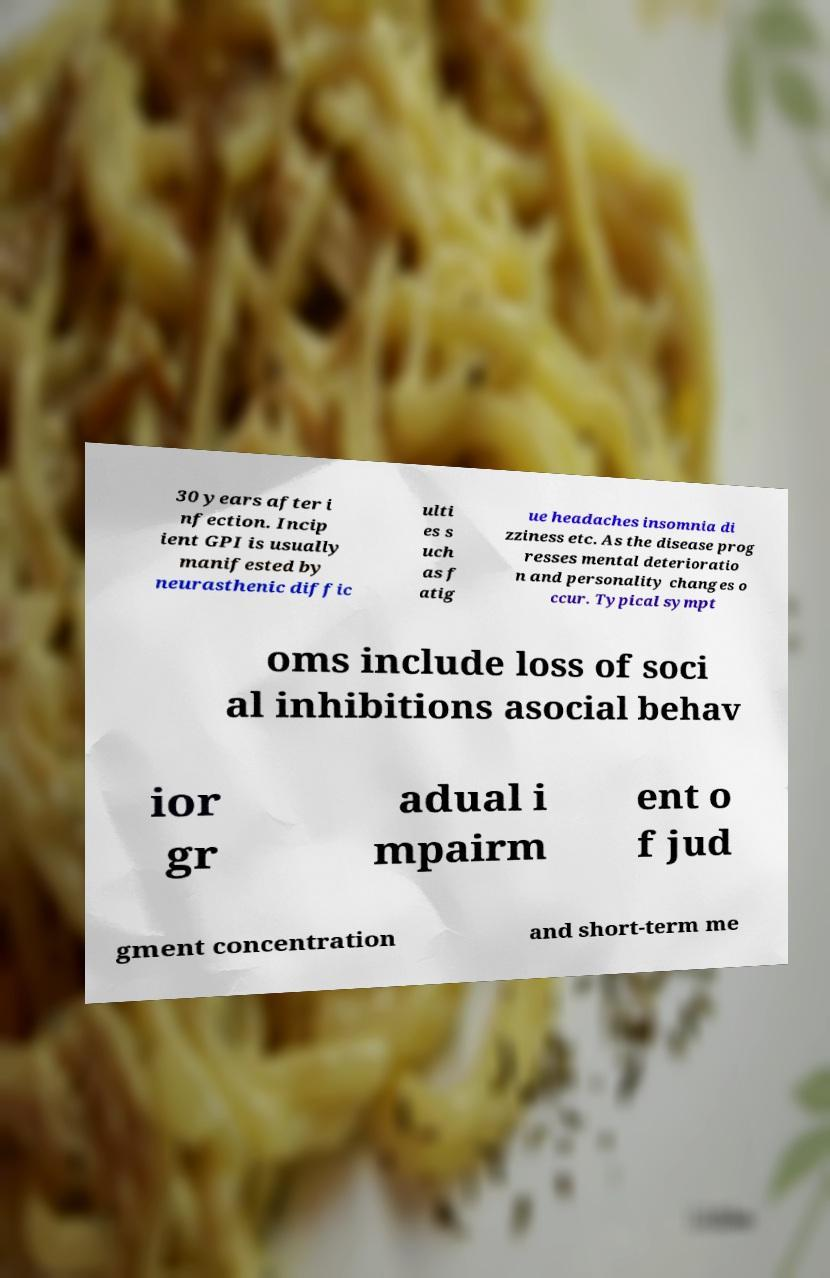There's text embedded in this image that I need extracted. Can you transcribe it verbatim? 30 years after i nfection. Incip ient GPI is usually manifested by neurasthenic diffic ulti es s uch as f atig ue headaches insomnia di zziness etc. As the disease prog resses mental deterioratio n and personality changes o ccur. Typical sympt oms include loss of soci al inhibitions asocial behav ior gr adual i mpairm ent o f jud gment concentration and short-term me 